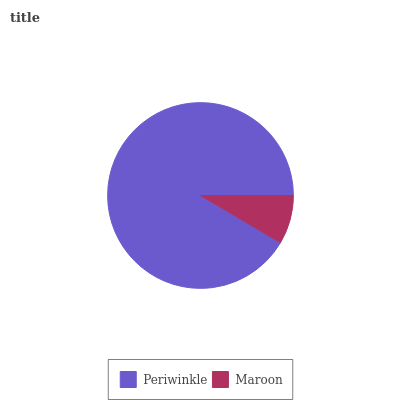Is Maroon the minimum?
Answer yes or no. Yes. Is Periwinkle the maximum?
Answer yes or no. Yes. Is Maroon the maximum?
Answer yes or no. No. Is Periwinkle greater than Maroon?
Answer yes or no. Yes. Is Maroon less than Periwinkle?
Answer yes or no. Yes. Is Maroon greater than Periwinkle?
Answer yes or no. No. Is Periwinkle less than Maroon?
Answer yes or no. No. Is Periwinkle the high median?
Answer yes or no. Yes. Is Maroon the low median?
Answer yes or no. Yes. Is Maroon the high median?
Answer yes or no. No. Is Periwinkle the low median?
Answer yes or no. No. 